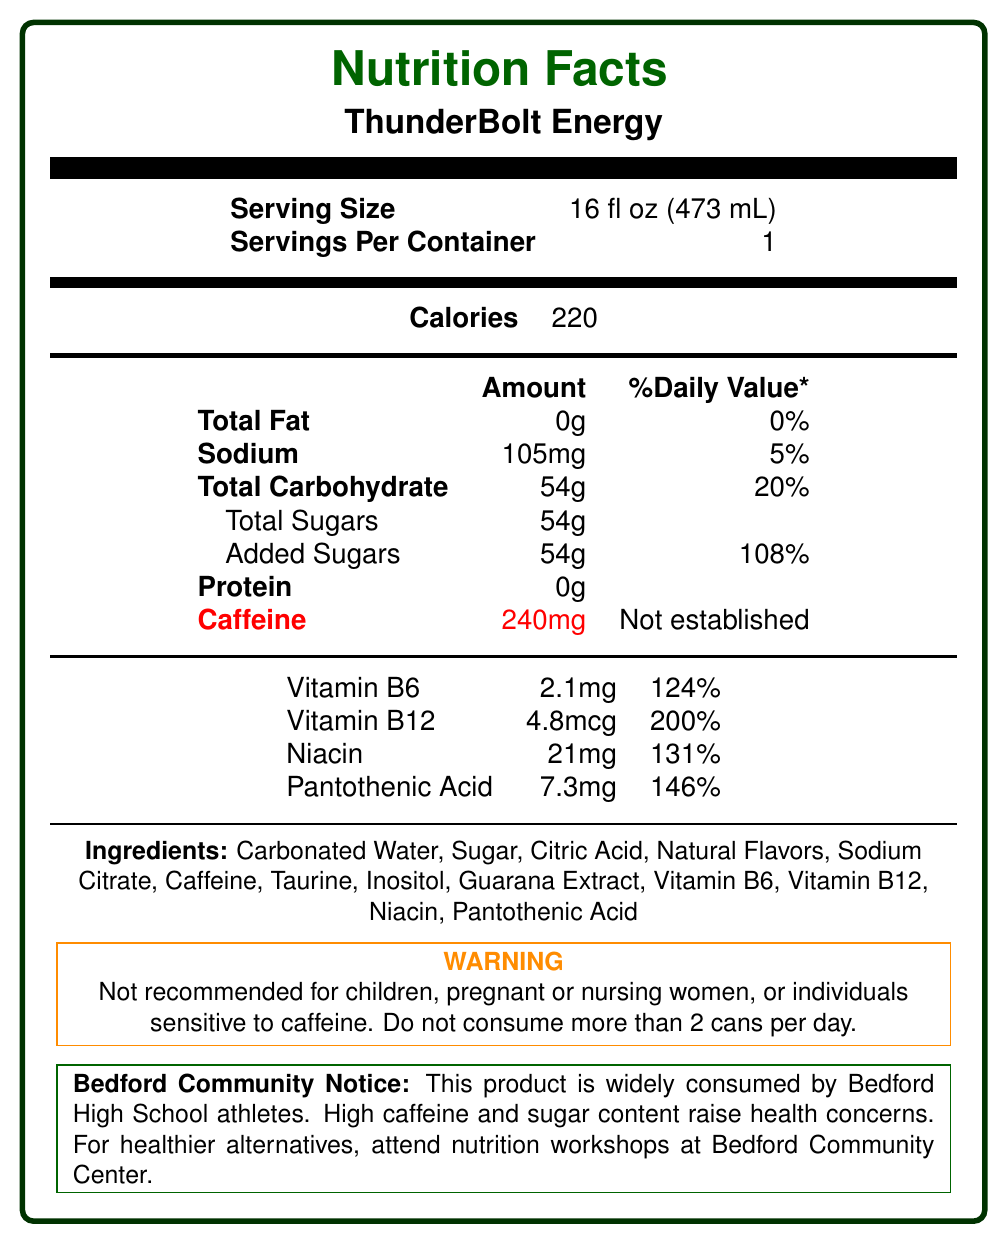what is the serving size of ThunderBolt Energy? The serving size is specified at the beginning of the nutrition facts section.
Answer: 16 fl oz (473 mL) how many calories are in a serving of ThunderBolt Energy? The number of calories per serving is listed directly under the serving size information.
Answer: 220 what is the total sugar content in a serving of ThunderBolt Energy? The total sugar content is listed under the Total Carbohydrate section.
Answer: 54g what is the daily value percentage of added sugars in ThunderBolt Energy? The daily value percentage for added sugars is listed next to the amount of added sugars.
Answer: 108% how many milligrams of caffeine are in a serving of ThunderBolt Energy? The amount of caffeine is listed under the nutritional information, highlighted in red.
Answer: 240mg which vitamins are present in ThunderBolt Energy and what are their daily values? These values are specified under the vitamins section of the nutrition label.
Answer: Vitamin B6 (124%), Vitamin B12 (200%), Niacin (131%), Pantothenic Acid (146%) how much sodium is in a serving of ThunderBolt Energy? The sodium amount is listed along with its daily value percentage under the Total Fat section.
Answer: 105mg what is the total carbohydrate content and its daily value percentage in ThunderBolt Energy? The total carbohydrate content and daily value percentage are listed under the Total Carbohydrate section.
Answer: 54g, 20% is it recommended for children to consume ThunderBolt Energy? The warning section explicitly states that this product is not recommended for children.
Answer: No what are some concerns raised by the Bedford community about ThunderBolt Energy? The community concerns are mentioned in the Bedford Community Notice section.
Answer: High caffeine and sugar content raising health concerns among parents and educators what are the ingredients in ThunderBolt Energy? The entire list of ingredients is provided in the ingredients section.
Answer: Carbonated Water, Sugar, Citric Acid, Natural Flavors, Sodium Citrate, Caffeine, Taurine, Inositol, Guarana Extract, Vitamin B6, Vitamin B12, Niacin, Pantothenic Acid how many servings are in one container of ThunderBolt Energy? The number of servings per container is listed under the serving size information.
Answer: 1 how often should someone consume ThunderBolt Energy according to the warning label? A. No more than 1 can per day B. No more than 2 cans per day C. No more than 3 cans per day The warning label states that individuals should not consume more than 2 cans per day.
Answer: B. No more than 2 cans per day what is the daily value percentage for sodium in ThunderBolt Energy? A. 3% B. 5% C. 8% D. 10% The daily value percentage for sodium is listed next to the sodium content.
Answer: B. 5% does ThunderBolt Energy contain any protein? The protein amount is listed as 0g.
Answer: No summarize the main concerns presented in the Bedford Community Notice section. This summary captures the key points from the Bedford Community Notice about the product's consumption and associated community concerns.
Answer: Bedford High School athletes are widely consuming ThunderBolt Energy, which has a high caffeine and sugar content, raising health concerns among parents and educators. The Bedford Community Center recommends healthier alternatives and offers nutrition workshops for teen athletes. what is the amount of taurine in ThunderBolt Energy? The document does not provide the specific amount of taurine in the drink, only that it is one of the ingredients.
Answer: Not enough information 